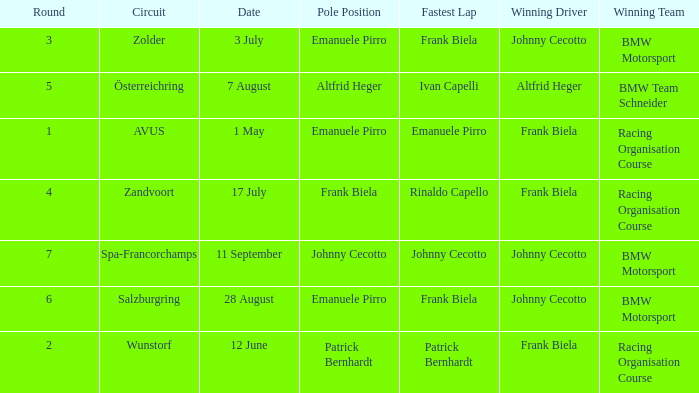Who was the winning team on the circuit Zolder? BMW Motorsport. 